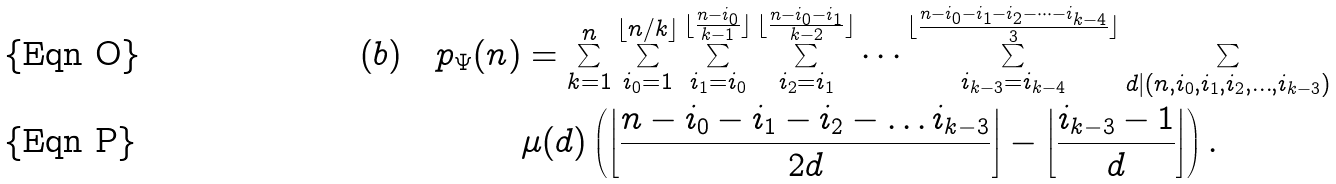<formula> <loc_0><loc_0><loc_500><loc_500>( b ) \quad p _ { \Psi } ( n ) & = \sum _ { k = 1 } ^ { n } \sum _ { i _ { 0 } = 1 } ^ { \lfloor n / k \rfloor } \sum _ { i _ { 1 } = i _ { 0 } } ^ { \lfloor \frac { n - i _ { 0 } } { k - 1 } \rfloor } \sum _ { i _ { 2 } = i _ { 1 } } ^ { \lfloor \frac { n - i _ { 0 } - i _ { 1 } } { k - 2 } \rfloor } \dots \sum _ { i _ { k - 3 } = i _ { k - 4 } } ^ { \lfloor \frac { n - i _ { 0 } - i _ { 1 } - i _ { 2 } - \dots - i _ { k - 4 } } { 3 } \rfloor } \sum _ { d | ( n , i _ { 0 } , i _ { 1 } , i _ { 2 } , \dots , i _ { k - 3 } ) } \\ & \mu ( d ) \left ( \left \lfloor \frac { n - i _ { 0 } - i _ { 1 } - i _ { 2 } - \dots i _ { k - 3 } } { 2 d } \right \rfloor - \left \lfloor \frac { i _ { k - 3 } - 1 } { d } \right \rfloor \right ) .</formula> 